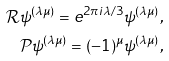<formula> <loc_0><loc_0><loc_500><loc_500>\mathcal { R } \psi ^ { ( \lambda \mu ) } = e ^ { 2 \pi i \lambda / 3 } \psi ^ { ( \lambda \mu ) } , \\ \mathcal { P } \psi ^ { ( \lambda \mu ) } = ( - 1 ) ^ { \mu } \psi ^ { ( \lambda \mu ) } ,</formula> 